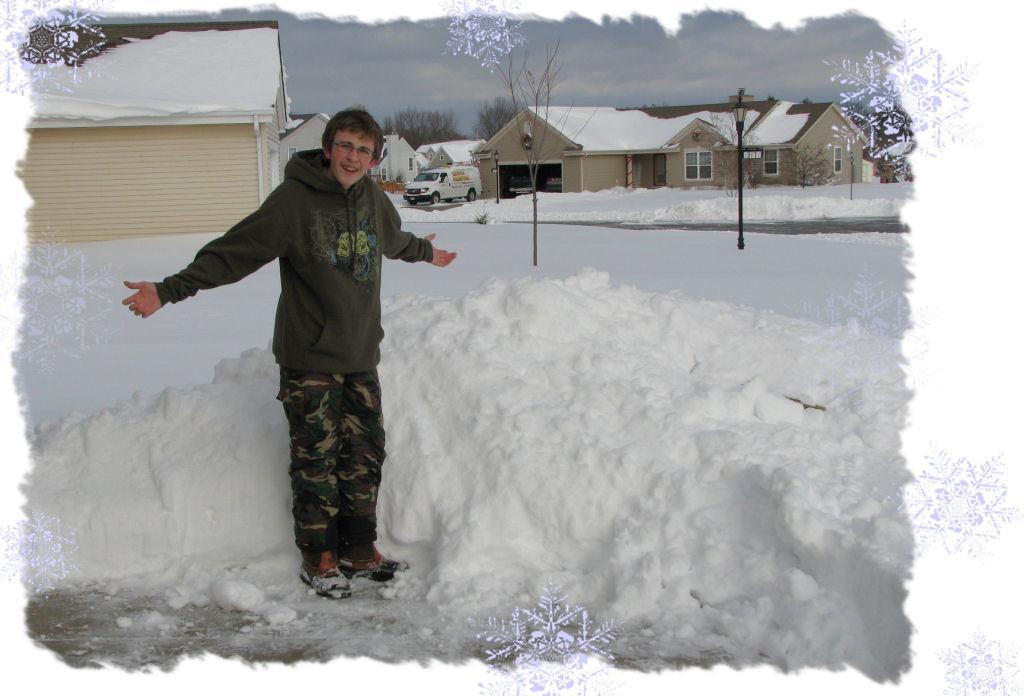Describe this image in one or two sentences. This is an edited image. In this image there is a person standing on the surface of the snow. In the background there are buildings, trees, there is a vehicle, mountains and the sky. 